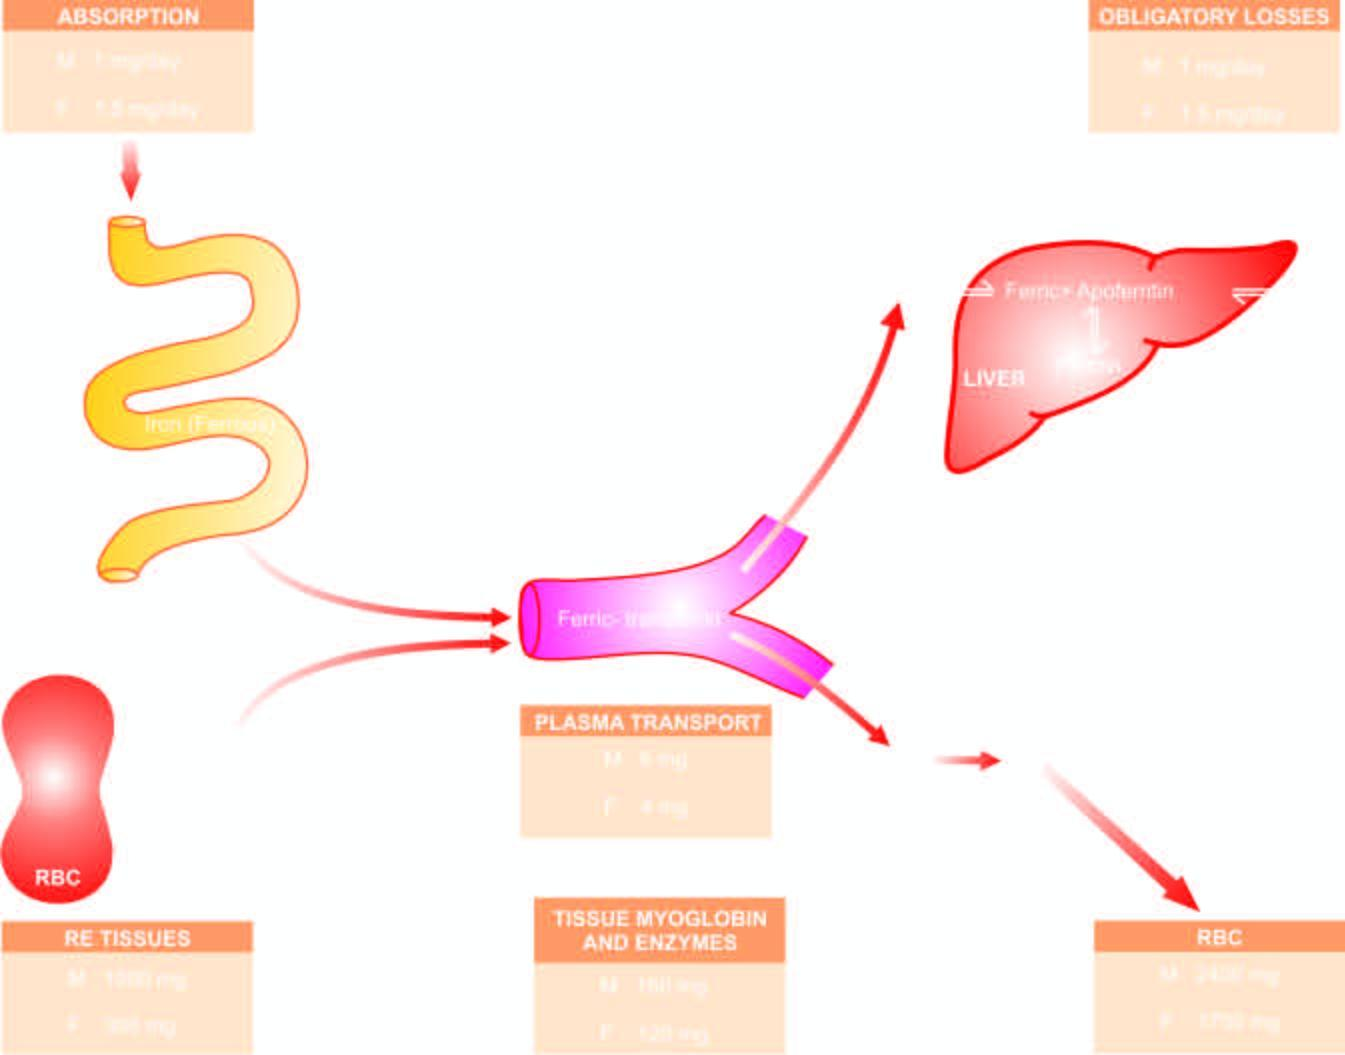what are the mature red cells released into, which on completion of their lifespan of 120 days, die?
Answer the question using a single word or phrase. Circulation 